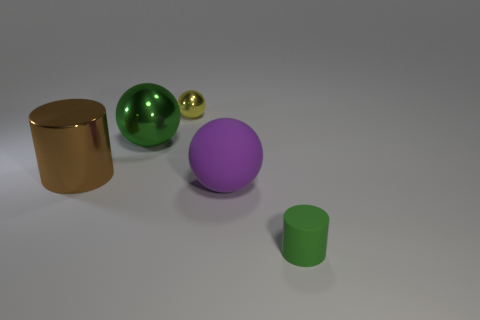Subtract all large spheres. How many spheres are left? 1 Add 4 small blue rubber objects. How many objects exist? 9 Subtract all cylinders. How many objects are left? 3 Add 2 green matte things. How many green matte things exist? 3 Subtract 0 blue cylinders. How many objects are left? 5 Subtract all small gray cylinders. Subtract all tiny matte cylinders. How many objects are left? 4 Add 2 tiny yellow metallic objects. How many tiny yellow metallic objects are left? 3 